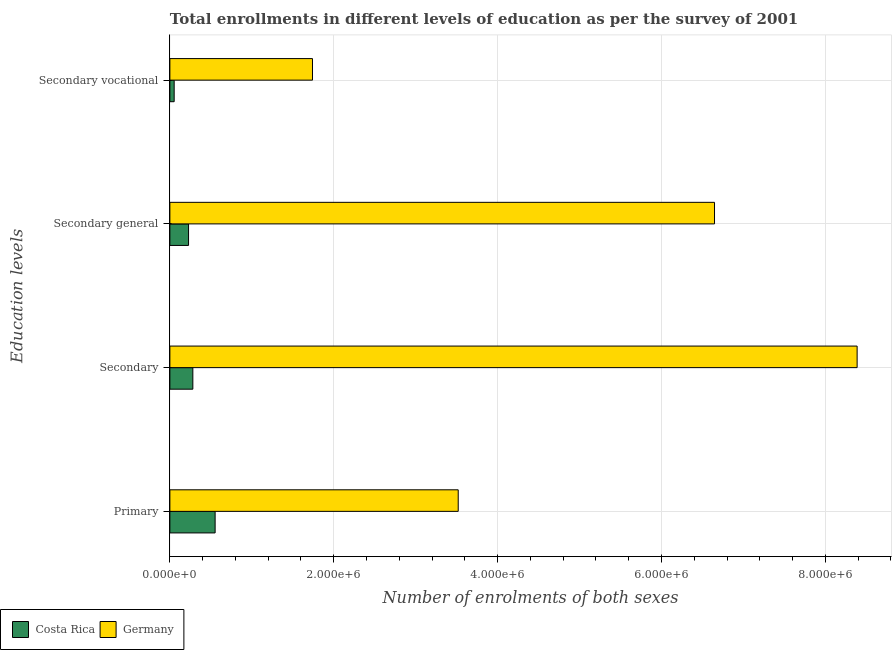How many different coloured bars are there?
Your answer should be very brief. 2. How many groups of bars are there?
Make the answer very short. 4. How many bars are there on the 4th tick from the top?
Your answer should be very brief. 2. What is the label of the 4th group of bars from the top?
Your response must be concise. Primary. What is the number of enrolments in secondary general education in Germany?
Provide a succinct answer. 6.65e+06. Across all countries, what is the maximum number of enrolments in secondary education?
Your answer should be very brief. 8.39e+06. Across all countries, what is the minimum number of enrolments in secondary general education?
Keep it short and to the point. 2.28e+05. What is the total number of enrolments in primary education in the graph?
Give a very brief answer. 4.07e+06. What is the difference between the number of enrolments in primary education in Costa Rica and that in Germany?
Your response must be concise. -2.97e+06. What is the difference between the number of enrolments in secondary vocational education in Costa Rica and the number of enrolments in secondary general education in Germany?
Keep it short and to the point. -6.59e+06. What is the average number of enrolments in primary education per country?
Your answer should be compact. 2.04e+06. What is the difference between the number of enrolments in secondary general education and number of enrolments in primary education in Germany?
Provide a succinct answer. 3.13e+06. In how many countries, is the number of enrolments in secondary general education greater than 2000000 ?
Your answer should be compact. 1. What is the ratio of the number of enrolments in secondary vocational education in Costa Rica to that in Germany?
Provide a succinct answer. 0.03. Is the number of enrolments in secondary vocational education in Costa Rica less than that in Germany?
Offer a terse response. Yes. What is the difference between the highest and the second highest number of enrolments in primary education?
Provide a succinct answer. 2.97e+06. What is the difference between the highest and the lowest number of enrolments in secondary education?
Your answer should be very brief. 8.11e+06. How many bars are there?
Your answer should be compact. 8. Are all the bars in the graph horizontal?
Your answer should be compact. Yes. Are the values on the major ticks of X-axis written in scientific E-notation?
Your answer should be compact. Yes. Does the graph contain grids?
Provide a succinct answer. Yes. How many legend labels are there?
Keep it short and to the point. 2. What is the title of the graph?
Your answer should be compact. Total enrollments in different levels of education as per the survey of 2001. Does "Vietnam" appear as one of the legend labels in the graph?
Provide a short and direct response. No. What is the label or title of the X-axis?
Offer a very short reply. Number of enrolments of both sexes. What is the label or title of the Y-axis?
Offer a terse response. Education levels. What is the Number of enrolments of both sexes in Costa Rica in Primary?
Your response must be concise. 5.52e+05. What is the Number of enrolments of both sexes in Germany in Primary?
Your answer should be very brief. 3.52e+06. What is the Number of enrolments of both sexes of Costa Rica in Secondary?
Give a very brief answer. 2.80e+05. What is the Number of enrolments of both sexes of Germany in Secondary?
Your response must be concise. 8.39e+06. What is the Number of enrolments of both sexes in Costa Rica in Secondary general?
Give a very brief answer. 2.28e+05. What is the Number of enrolments of both sexes in Germany in Secondary general?
Provide a short and direct response. 6.65e+06. What is the Number of enrolments of both sexes in Costa Rica in Secondary vocational?
Offer a very short reply. 5.24e+04. What is the Number of enrolments of both sexes of Germany in Secondary vocational?
Your response must be concise. 1.74e+06. Across all Education levels, what is the maximum Number of enrolments of both sexes in Costa Rica?
Make the answer very short. 5.52e+05. Across all Education levels, what is the maximum Number of enrolments of both sexes in Germany?
Give a very brief answer. 8.39e+06. Across all Education levels, what is the minimum Number of enrolments of both sexes of Costa Rica?
Provide a succinct answer. 5.24e+04. Across all Education levels, what is the minimum Number of enrolments of both sexes in Germany?
Make the answer very short. 1.74e+06. What is the total Number of enrolments of both sexes of Costa Rica in the graph?
Your answer should be compact. 1.11e+06. What is the total Number of enrolments of both sexes in Germany in the graph?
Make the answer very short. 2.03e+07. What is the difference between the Number of enrolments of both sexes of Costa Rica in Primary and that in Secondary?
Offer a terse response. 2.72e+05. What is the difference between the Number of enrolments of both sexes of Germany in Primary and that in Secondary?
Your answer should be very brief. -4.87e+06. What is the difference between the Number of enrolments of both sexes of Costa Rica in Primary and that in Secondary general?
Your answer should be compact. 3.24e+05. What is the difference between the Number of enrolments of both sexes in Germany in Primary and that in Secondary general?
Keep it short and to the point. -3.13e+06. What is the difference between the Number of enrolments of both sexes in Costa Rica in Primary and that in Secondary vocational?
Your answer should be compact. 5.00e+05. What is the difference between the Number of enrolments of both sexes of Germany in Primary and that in Secondary vocational?
Your answer should be very brief. 1.78e+06. What is the difference between the Number of enrolments of both sexes in Costa Rica in Secondary and that in Secondary general?
Your response must be concise. 5.24e+04. What is the difference between the Number of enrolments of both sexes of Germany in Secondary and that in Secondary general?
Offer a very short reply. 1.74e+06. What is the difference between the Number of enrolments of both sexes of Costa Rica in Secondary and that in Secondary vocational?
Make the answer very short. 2.28e+05. What is the difference between the Number of enrolments of both sexes of Germany in Secondary and that in Secondary vocational?
Make the answer very short. 6.65e+06. What is the difference between the Number of enrolments of both sexes in Costa Rica in Secondary general and that in Secondary vocational?
Make the answer very short. 1.76e+05. What is the difference between the Number of enrolments of both sexes of Germany in Secondary general and that in Secondary vocational?
Make the answer very short. 4.91e+06. What is the difference between the Number of enrolments of both sexes of Costa Rica in Primary and the Number of enrolments of both sexes of Germany in Secondary?
Your answer should be very brief. -7.84e+06. What is the difference between the Number of enrolments of both sexes in Costa Rica in Primary and the Number of enrolments of both sexes in Germany in Secondary general?
Ensure brevity in your answer.  -6.09e+06. What is the difference between the Number of enrolments of both sexes of Costa Rica in Primary and the Number of enrolments of both sexes of Germany in Secondary vocational?
Offer a very short reply. -1.19e+06. What is the difference between the Number of enrolments of both sexes in Costa Rica in Secondary and the Number of enrolments of both sexes in Germany in Secondary general?
Provide a succinct answer. -6.37e+06. What is the difference between the Number of enrolments of both sexes in Costa Rica in Secondary and the Number of enrolments of both sexes in Germany in Secondary vocational?
Your answer should be very brief. -1.46e+06. What is the difference between the Number of enrolments of both sexes of Costa Rica in Secondary general and the Number of enrolments of both sexes of Germany in Secondary vocational?
Give a very brief answer. -1.51e+06. What is the average Number of enrolments of both sexes of Costa Rica per Education levels?
Keep it short and to the point. 2.78e+05. What is the average Number of enrolments of both sexes in Germany per Education levels?
Provide a succinct answer. 5.07e+06. What is the difference between the Number of enrolments of both sexes of Costa Rica and Number of enrolments of both sexes of Germany in Primary?
Provide a succinct answer. -2.97e+06. What is the difference between the Number of enrolments of both sexes of Costa Rica and Number of enrolments of both sexes of Germany in Secondary?
Your answer should be very brief. -8.11e+06. What is the difference between the Number of enrolments of both sexes in Costa Rica and Number of enrolments of both sexes in Germany in Secondary general?
Provide a succinct answer. -6.42e+06. What is the difference between the Number of enrolments of both sexes of Costa Rica and Number of enrolments of both sexes of Germany in Secondary vocational?
Make the answer very short. -1.69e+06. What is the ratio of the Number of enrolments of both sexes of Costa Rica in Primary to that in Secondary?
Offer a very short reply. 1.97. What is the ratio of the Number of enrolments of both sexes in Germany in Primary to that in Secondary?
Your response must be concise. 0.42. What is the ratio of the Number of enrolments of both sexes in Costa Rica in Primary to that in Secondary general?
Your response must be concise. 2.42. What is the ratio of the Number of enrolments of both sexes in Germany in Primary to that in Secondary general?
Offer a very short reply. 0.53. What is the ratio of the Number of enrolments of both sexes in Costa Rica in Primary to that in Secondary vocational?
Your response must be concise. 10.54. What is the ratio of the Number of enrolments of both sexes in Germany in Primary to that in Secondary vocational?
Make the answer very short. 2.02. What is the ratio of the Number of enrolments of both sexes of Costa Rica in Secondary to that in Secondary general?
Give a very brief answer. 1.23. What is the ratio of the Number of enrolments of both sexes in Germany in Secondary to that in Secondary general?
Ensure brevity in your answer.  1.26. What is the ratio of the Number of enrolments of both sexes in Costa Rica in Secondary to that in Secondary vocational?
Give a very brief answer. 5.35. What is the ratio of the Number of enrolments of both sexes in Germany in Secondary to that in Secondary vocational?
Give a very brief answer. 4.82. What is the ratio of the Number of enrolments of both sexes of Costa Rica in Secondary general to that in Secondary vocational?
Provide a short and direct response. 4.35. What is the ratio of the Number of enrolments of both sexes in Germany in Secondary general to that in Secondary vocational?
Offer a terse response. 3.82. What is the difference between the highest and the second highest Number of enrolments of both sexes of Costa Rica?
Provide a succinct answer. 2.72e+05. What is the difference between the highest and the second highest Number of enrolments of both sexes in Germany?
Give a very brief answer. 1.74e+06. What is the difference between the highest and the lowest Number of enrolments of both sexes in Costa Rica?
Your answer should be very brief. 5.00e+05. What is the difference between the highest and the lowest Number of enrolments of both sexes of Germany?
Ensure brevity in your answer.  6.65e+06. 